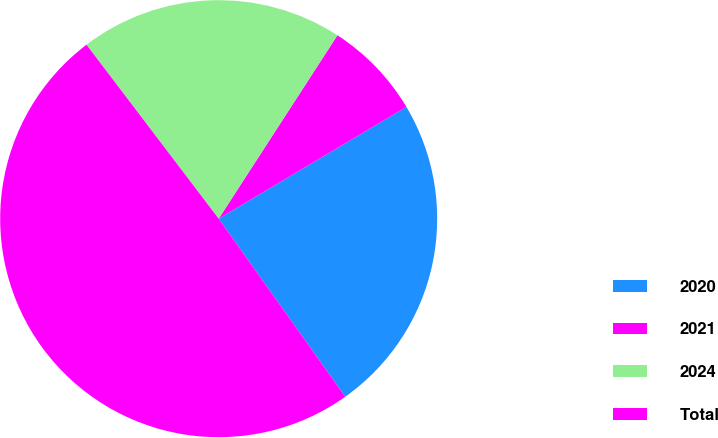<chart> <loc_0><loc_0><loc_500><loc_500><pie_chart><fcel>2020<fcel>2021<fcel>2024<fcel>Total<nl><fcel>23.71%<fcel>7.31%<fcel>19.49%<fcel>49.5%<nl></chart> 